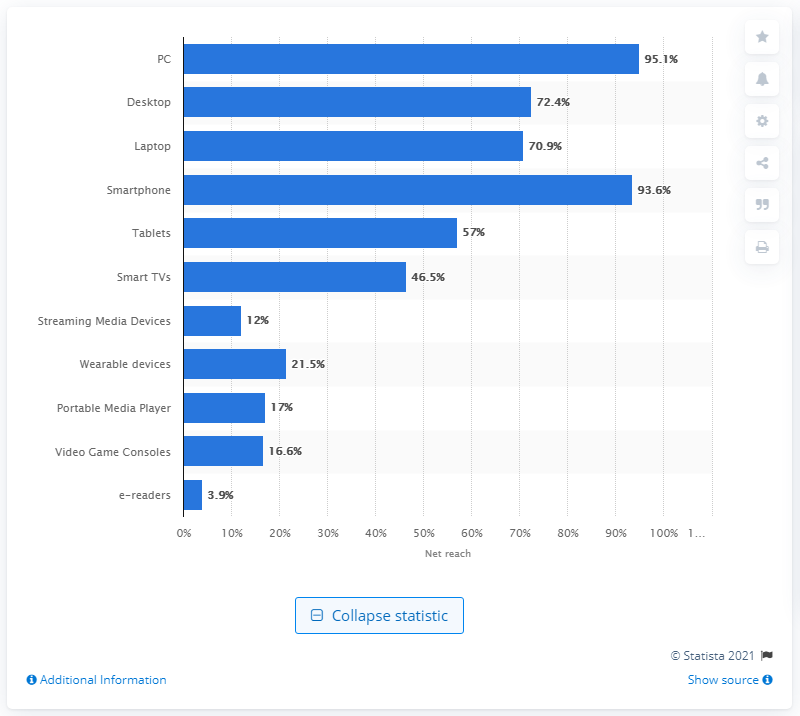List a handful of essential elements in this visual. According to a recent survey, a staggering 95.1% of Chinese internet users accessed a personal computer in the past month. As of May 2016, the usage penetration rate of smartphones among online users in China was 93.6%. This means that 93.6% of online users in China were using smartphones to access the internet. 